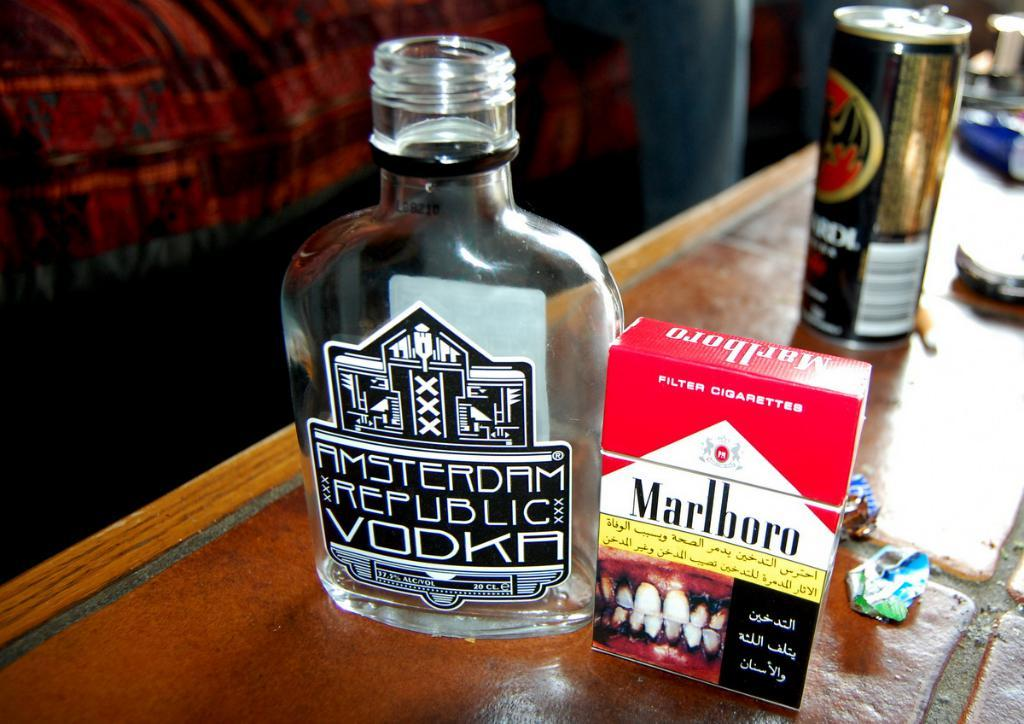<image>
Offer a succinct explanation of the picture presented. an Amsterdam Vodka next to a Marlboro pack with a image of gross teeth 